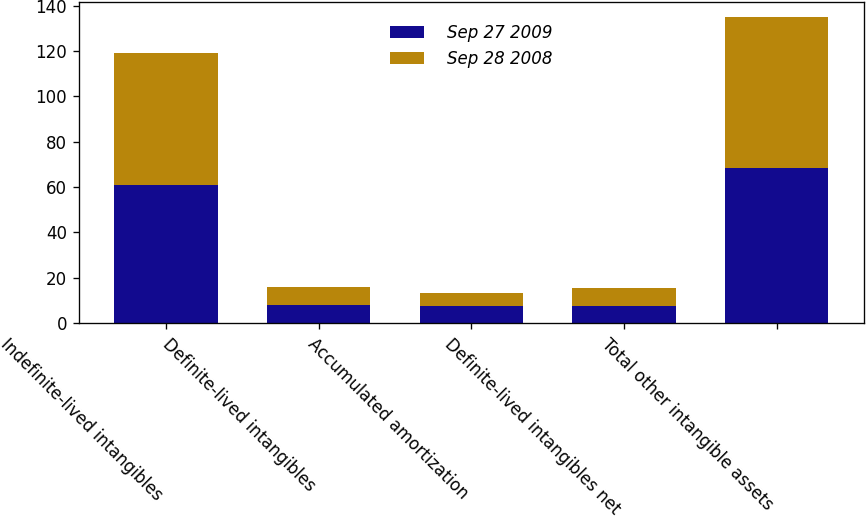Convert chart. <chart><loc_0><loc_0><loc_500><loc_500><stacked_bar_chart><ecel><fcel>Indefinite-lived intangibles<fcel>Definite-lived intangibles<fcel>Accumulated amortization<fcel>Definite-lived intangibles net<fcel>Total other intangible assets<nl><fcel>Sep 27 2009<fcel>60.8<fcel>8<fcel>7.6<fcel>7.4<fcel>68.2<nl><fcel>Sep 28 2008<fcel>58.3<fcel>8<fcel>5.9<fcel>8.3<fcel>66.6<nl></chart> 